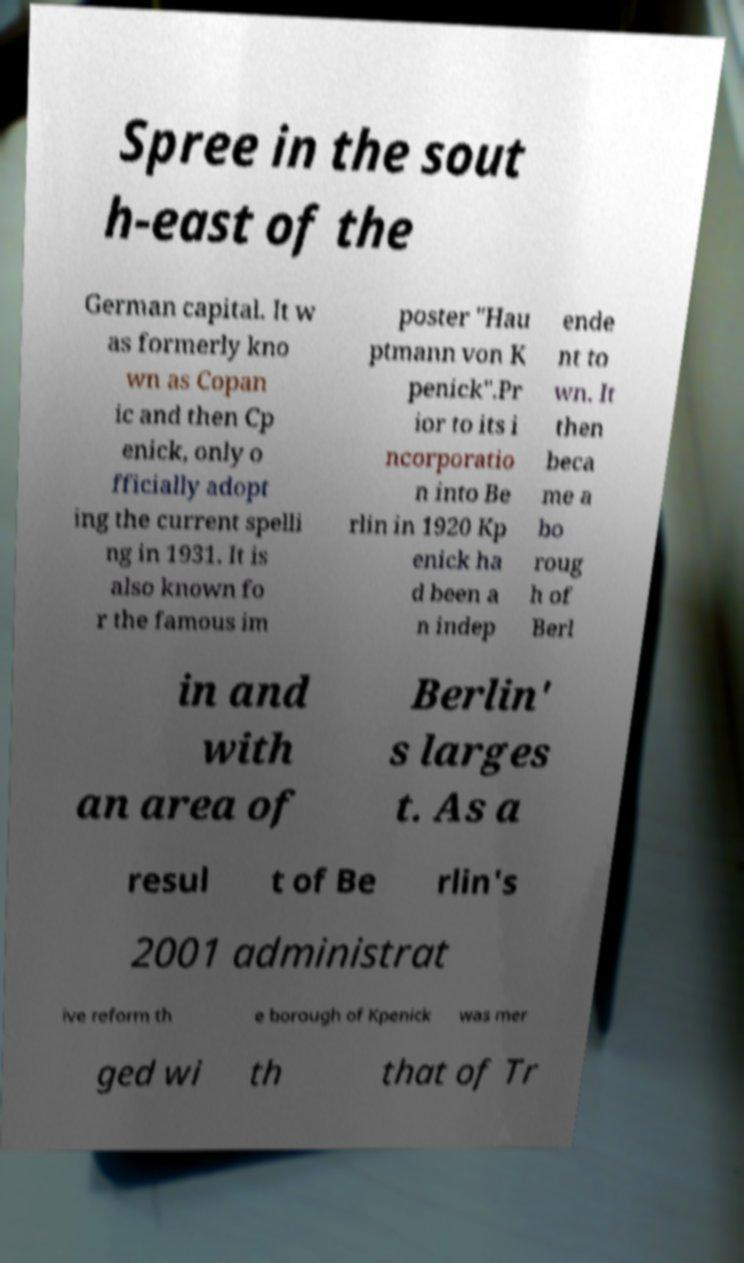Can you accurately transcribe the text from the provided image for me? Spree in the sout h-east of the German capital. It w as formerly kno wn as Copan ic and then Cp enick, only o fficially adopt ing the current spelli ng in 1931. It is also known fo r the famous im poster "Hau ptmann von K penick".Pr ior to its i ncorporatio n into Be rlin in 1920 Kp enick ha d been a n indep ende nt to wn. It then beca me a bo roug h of Berl in and with an area of Berlin' s larges t. As a resul t of Be rlin's 2001 administrat ive reform th e borough of Kpenick was mer ged wi th that of Tr 